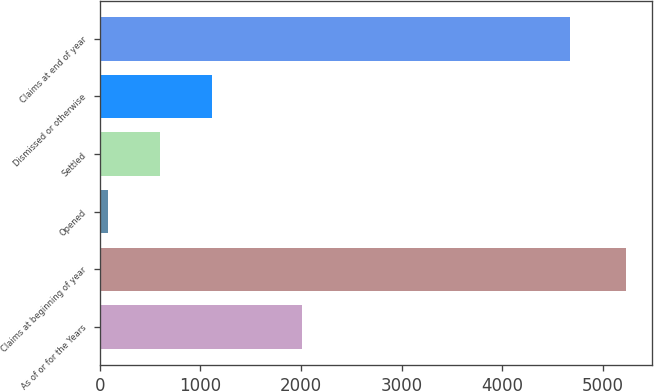Convert chart to OTSL. <chart><loc_0><loc_0><loc_500><loc_500><bar_chart><fcel>As of or for the Years<fcel>Claims at beginning of year<fcel>Opened<fcel>Settled<fcel>Dismissed or otherwise<fcel>Claims at end of year<nl><fcel>2013<fcel>5230<fcel>83<fcel>597.7<fcel>1112.4<fcel>4680<nl></chart> 